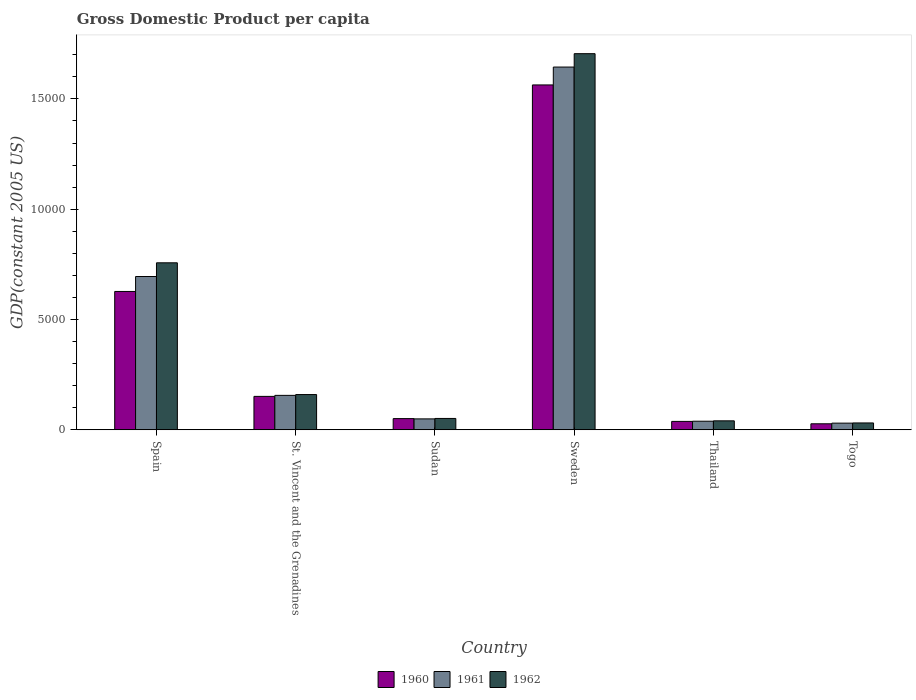How many different coloured bars are there?
Provide a succinct answer. 3. Are the number of bars per tick equal to the number of legend labels?
Keep it short and to the point. Yes. What is the label of the 2nd group of bars from the left?
Provide a short and direct response. St. Vincent and the Grenadines. What is the GDP per capita in 1962 in Sudan?
Your answer should be very brief. 515.24. Across all countries, what is the maximum GDP per capita in 1962?
Make the answer very short. 1.71e+04. Across all countries, what is the minimum GDP per capita in 1961?
Provide a succinct answer. 302.44. In which country was the GDP per capita in 1960 minimum?
Offer a very short reply. Togo. What is the total GDP per capita in 1960 in the graph?
Give a very brief answer. 2.46e+04. What is the difference between the GDP per capita in 1960 in Sweden and that in Thailand?
Your answer should be very brief. 1.53e+04. What is the difference between the GDP per capita in 1961 in Togo and the GDP per capita in 1962 in Spain?
Give a very brief answer. -7268.8. What is the average GDP per capita in 1962 per country?
Give a very brief answer. 4575.63. What is the difference between the GDP per capita of/in 1960 and GDP per capita of/in 1961 in St. Vincent and the Grenadines?
Offer a very short reply. -45.55. What is the ratio of the GDP per capita in 1960 in Spain to that in Sudan?
Ensure brevity in your answer.  12.35. Is the GDP per capita in 1961 in Sweden less than that in Thailand?
Provide a short and direct response. No. Is the difference between the GDP per capita in 1960 in Sweden and Togo greater than the difference between the GDP per capita in 1961 in Sweden and Togo?
Keep it short and to the point. No. What is the difference between the highest and the second highest GDP per capita in 1962?
Offer a very short reply. 9480.54. What is the difference between the highest and the lowest GDP per capita in 1960?
Provide a short and direct response. 1.54e+04. In how many countries, is the GDP per capita in 1961 greater than the average GDP per capita in 1961 taken over all countries?
Your answer should be very brief. 2. Is the sum of the GDP per capita in 1962 in Spain and Togo greater than the maximum GDP per capita in 1961 across all countries?
Ensure brevity in your answer.  No. How many countries are there in the graph?
Provide a short and direct response. 6. What is the difference between two consecutive major ticks on the Y-axis?
Make the answer very short. 5000. Does the graph contain grids?
Your answer should be compact. No. How are the legend labels stacked?
Offer a very short reply. Horizontal. What is the title of the graph?
Ensure brevity in your answer.  Gross Domestic Product per capita. Does "1961" appear as one of the legend labels in the graph?
Your answer should be compact. Yes. What is the label or title of the Y-axis?
Offer a very short reply. GDP(constant 2005 US). What is the GDP(constant 2005 US) in 1960 in Spain?
Your answer should be very brief. 6271.86. What is the GDP(constant 2005 US) of 1961 in Spain?
Your answer should be very brief. 6949.5. What is the GDP(constant 2005 US) of 1962 in Spain?
Offer a very short reply. 7571.23. What is the GDP(constant 2005 US) in 1960 in St. Vincent and the Grenadines?
Provide a short and direct response. 1515.48. What is the GDP(constant 2005 US) in 1961 in St. Vincent and the Grenadines?
Provide a succinct answer. 1561.03. What is the GDP(constant 2005 US) in 1962 in St. Vincent and the Grenadines?
Give a very brief answer. 1598.04. What is the GDP(constant 2005 US) in 1960 in Sudan?
Your answer should be compact. 507.97. What is the GDP(constant 2005 US) of 1961 in Sudan?
Ensure brevity in your answer.  494.94. What is the GDP(constant 2005 US) of 1962 in Sudan?
Keep it short and to the point. 515.24. What is the GDP(constant 2005 US) of 1960 in Sweden?
Your answer should be very brief. 1.56e+04. What is the GDP(constant 2005 US) in 1961 in Sweden?
Ensure brevity in your answer.  1.64e+04. What is the GDP(constant 2005 US) in 1962 in Sweden?
Your answer should be very brief. 1.71e+04. What is the GDP(constant 2005 US) of 1960 in Thailand?
Your response must be concise. 380.85. What is the GDP(constant 2005 US) of 1961 in Thailand?
Give a very brief answer. 389.52. What is the GDP(constant 2005 US) of 1962 in Thailand?
Your response must be concise. 406.6. What is the GDP(constant 2005 US) of 1960 in Togo?
Offer a terse response. 272.53. What is the GDP(constant 2005 US) in 1961 in Togo?
Keep it short and to the point. 302.44. What is the GDP(constant 2005 US) in 1962 in Togo?
Your response must be concise. 310.89. Across all countries, what is the maximum GDP(constant 2005 US) in 1960?
Offer a very short reply. 1.56e+04. Across all countries, what is the maximum GDP(constant 2005 US) in 1961?
Provide a succinct answer. 1.64e+04. Across all countries, what is the maximum GDP(constant 2005 US) in 1962?
Provide a succinct answer. 1.71e+04. Across all countries, what is the minimum GDP(constant 2005 US) in 1960?
Keep it short and to the point. 272.53. Across all countries, what is the minimum GDP(constant 2005 US) in 1961?
Give a very brief answer. 302.44. Across all countries, what is the minimum GDP(constant 2005 US) of 1962?
Offer a terse response. 310.89. What is the total GDP(constant 2005 US) in 1960 in the graph?
Make the answer very short. 2.46e+04. What is the total GDP(constant 2005 US) of 1961 in the graph?
Ensure brevity in your answer.  2.61e+04. What is the total GDP(constant 2005 US) in 1962 in the graph?
Give a very brief answer. 2.75e+04. What is the difference between the GDP(constant 2005 US) of 1960 in Spain and that in St. Vincent and the Grenadines?
Provide a short and direct response. 4756.38. What is the difference between the GDP(constant 2005 US) of 1961 in Spain and that in St. Vincent and the Grenadines?
Make the answer very short. 5388.47. What is the difference between the GDP(constant 2005 US) in 1962 in Spain and that in St. Vincent and the Grenadines?
Provide a short and direct response. 5973.2. What is the difference between the GDP(constant 2005 US) of 1960 in Spain and that in Sudan?
Ensure brevity in your answer.  5763.88. What is the difference between the GDP(constant 2005 US) in 1961 in Spain and that in Sudan?
Your answer should be very brief. 6454.56. What is the difference between the GDP(constant 2005 US) of 1962 in Spain and that in Sudan?
Give a very brief answer. 7055.99. What is the difference between the GDP(constant 2005 US) in 1960 in Spain and that in Sweden?
Your answer should be compact. -9363.18. What is the difference between the GDP(constant 2005 US) in 1961 in Spain and that in Sweden?
Your answer should be very brief. -9496.2. What is the difference between the GDP(constant 2005 US) of 1962 in Spain and that in Sweden?
Your answer should be compact. -9480.54. What is the difference between the GDP(constant 2005 US) in 1960 in Spain and that in Thailand?
Your answer should be very brief. 5891. What is the difference between the GDP(constant 2005 US) in 1961 in Spain and that in Thailand?
Give a very brief answer. 6559.98. What is the difference between the GDP(constant 2005 US) in 1962 in Spain and that in Thailand?
Your answer should be very brief. 7164.64. What is the difference between the GDP(constant 2005 US) in 1960 in Spain and that in Togo?
Give a very brief answer. 5999.33. What is the difference between the GDP(constant 2005 US) of 1961 in Spain and that in Togo?
Give a very brief answer. 6647.06. What is the difference between the GDP(constant 2005 US) of 1962 in Spain and that in Togo?
Make the answer very short. 7260.35. What is the difference between the GDP(constant 2005 US) in 1960 in St. Vincent and the Grenadines and that in Sudan?
Your response must be concise. 1007.51. What is the difference between the GDP(constant 2005 US) in 1961 in St. Vincent and the Grenadines and that in Sudan?
Your response must be concise. 1066.09. What is the difference between the GDP(constant 2005 US) of 1962 in St. Vincent and the Grenadines and that in Sudan?
Your response must be concise. 1082.79. What is the difference between the GDP(constant 2005 US) of 1960 in St. Vincent and the Grenadines and that in Sweden?
Offer a very short reply. -1.41e+04. What is the difference between the GDP(constant 2005 US) in 1961 in St. Vincent and the Grenadines and that in Sweden?
Offer a terse response. -1.49e+04. What is the difference between the GDP(constant 2005 US) of 1962 in St. Vincent and the Grenadines and that in Sweden?
Provide a short and direct response. -1.55e+04. What is the difference between the GDP(constant 2005 US) in 1960 in St. Vincent and the Grenadines and that in Thailand?
Provide a short and direct response. 1134.63. What is the difference between the GDP(constant 2005 US) in 1961 in St. Vincent and the Grenadines and that in Thailand?
Provide a succinct answer. 1171.51. What is the difference between the GDP(constant 2005 US) in 1962 in St. Vincent and the Grenadines and that in Thailand?
Your answer should be very brief. 1191.44. What is the difference between the GDP(constant 2005 US) in 1960 in St. Vincent and the Grenadines and that in Togo?
Ensure brevity in your answer.  1242.95. What is the difference between the GDP(constant 2005 US) in 1961 in St. Vincent and the Grenadines and that in Togo?
Your response must be concise. 1258.59. What is the difference between the GDP(constant 2005 US) in 1962 in St. Vincent and the Grenadines and that in Togo?
Provide a short and direct response. 1287.15. What is the difference between the GDP(constant 2005 US) of 1960 in Sudan and that in Sweden?
Offer a terse response. -1.51e+04. What is the difference between the GDP(constant 2005 US) of 1961 in Sudan and that in Sweden?
Offer a very short reply. -1.60e+04. What is the difference between the GDP(constant 2005 US) of 1962 in Sudan and that in Sweden?
Offer a very short reply. -1.65e+04. What is the difference between the GDP(constant 2005 US) in 1960 in Sudan and that in Thailand?
Your answer should be very brief. 127.12. What is the difference between the GDP(constant 2005 US) in 1961 in Sudan and that in Thailand?
Provide a short and direct response. 105.42. What is the difference between the GDP(constant 2005 US) in 1962 in Sudan and that in Thailand?
Your answer should be very brief. 108.64. What is the difference between the GDP(constant 2005 US) of 1960 in Sudan and that in Togo?
Keep it short and to the point. 235.45. What is the difference between the GDP(constant 2005 US) of 1961 in Sudan and that in Togo?
Offer a very short reply. 192.5. What is the difference between the GDP(constant 2005 US) of 1962 in Sudan and that in Togo?
Provide a succinct answer. 204.36. What is the difference between the GDP(constant 2005 US) in 1960 in Sweden and that in Thailand?
Ensure brevity in your answer.  1.53e+04. What is the difference between the GDP(constant 2005 US) in 1961 in Sweden and that in Thailand?
Keep it short and to the point. 1.61e+04. What is the difference between the GDP(constant 2005 US) of 1962 in Sweden and that in Thailand?
Your answer should be compact. 1.66e+04. What is the difference between the GDP(constant 2005 US) of 1960 in Sweden and that in Togo?
Your answer should be compact. 1.54e+04. What is the difference between the GDP(constant 2005 US) in 1961 in Sweden and that in Togo?
Your answer should be very brief. 1.61e+04. What is the difference between the GDP(constant 2005 US) in 1962 in Sweden and that in Togo?
Your answer should be compact. 1.67e+04. What is the difference between the GDP(constant 2005 US) of 1960 in Thailand and that in Togo?
Ensure brevity in your answer.  108.32. What is the difference between the GDP(constant 2005 US) of 1961 in Thailand and that in Togo?
Your answer should be compact. 87.08. What is the difference between the GDP(constant 2005 US) of 1962 in Thailand and that in Togo?
Provide a succinct answer. 95.71. What is the difference between the GDP(constant 2005 US) in 1960 in Spain and the GDP(constant 2005 US) in 1961 in St. Vincent and the Grenadines?
Ensure brevity in your answer.  4710.83. What is the difference between the GDP(constant 2005 US) of 1960 in Spain and the GDP(constant 2005 US) of 1962 in St. Vincent and the Grenadines?
Your answer should be very brief. 4673.82. What is the difference between the GDP(constant 2005 US) in 1961 in Spain and the GDP(constant 2005 US) in 1962 in St. Vincent and the Grenadines?
Keep it short and to the point. 5351.46. What is the difference between the GDP(constant 2005 US) of 1960 in Spain and the GDP(constant 2005 US) of 1961 in Sudan?
Your answer should be very brief. 5776.92. What is the difference between the GDP(constant 2005 US) in 1960 in Spain and the GDP(constant 2005 US) in 1962 in Sudan?
Keep it short and to the point. 5756.61. What is the difference between the GDP(constant 2005 US) in 1961 in Spain and the GDP(constant 2005 US) in 1962 in Sudan?
Make the answer very short. 6434.26. What is the difference between the GDP(constant 2005 US) of 1960 in Spain and the GDP(constant 2005 US) of 1961 in Sweden?
Your answer should be compact. -1.02e+04. What is the difference between the GDP(constant 2005 US) of 1960 in Spain and the GDP(constant 2005 US) of 1962 in Sweden?
Keep it short and to the point. -1.08e+04. What is the difference between the GDP(constant 2005 US) in 1961 in Spain and the GDP(constant 2005 US) in 1962 in Sweden?
Provide a short and direct response. -1.01e+04. What is the difference between the GDP(constant 2005 US) in 1960 in Spain and the GDP(constant 2005 US) in 1961 in Thailand?
Your answer should be compact. 5882.34. What is the difference between the GDP(constant 2005 US) of 1960 in Spain and the GDP(constant 2005 US) of 1962 in Thailand?
Your response must be concise. 5865.26. What is the difference between the GDP(constant 2005 US) in 1961 in Spain and the GDP(constant 2005 US) in 1962 in Thailand?
Give a very brief answer. 6542.9. What is the difference between the GDP(constant 2005 US) of 1960 in Spain and the GDP(constant 2005 US) of 1961 in Togo?
Your answer should be compact. 5969.42. What is the difference between the GDP(constant 2005 US) in 1960 in Spain and the GDP(constant 2005 US) in 1962 in Togo?
Keep it short and to the point. 5960.97. What is the difference between the GDP(constant 2005 US) of 1961 in Spain and the GDP(constant 2005 US) of 1962 in Togo?
Ensure brevity in your answer.  6638.61. What is the difference between the GDP(constant 2005 US) in 1960 in St. Vincent and the Grenadines and the GDP(constant 2005 US) in 1961 in Sudan?
Your response must be concise. 1020.54. What is the difference between the GDP(constant 2005 US) in 1960 in St. Vincent and the Grenadines and the GDP(constant 2005 US) in 1962 in Sudan?
Keep it short and to the point. 1000.24. What is the difference between the GDP(constant 2005 US) of 1961 in St. Vincent and the Grenadines and the GDP(constant 2005 US) of 1962 in Sudan?
Make the answer very short. 1045.78. What is the difference between the GDP(constant 2005 US) of 1960 in St. Vincent and the Grenadines and the GDP(constant 2005 US) of 1961 in Sweden?
Keep it short and to the point. -1.49e+04. What is the difference between the GDP(constant 2005 US) in 1960 in St. Vincent and the Grenadines and the GDP(constant 2005 US) in 1962 in Sweden?
Your answer should be very brief. -1.55e+04. What is the difference between the GDP(constant 2005 US) in 1961 in St. Vincent and the Grenadines and the GDP(constant 2005 US) in 1962 in Sweden?
Ensure brevity in your answer.  -1.55e+04. What is the difference between the GDP(constant 2005 US) in 1960 in St. Vincent and the Grenadines and the GDP(constant 2005 US) in 1961 in Thailand?
Your answer should be compact. 1125.96. What is the difference between the GDP(constant 2005 US) of 1960 in St. Vincent and the Grenadines and the GDP(constant 2005 US) of 1962 in Thailand?
Keep it short and to the point. 1108.88. What is the difference between the GDP(constant 2005 US) in 1961 in St. Vincent and the Grenadines and the GDP(constant 2005 US) in 1962 in Thailand?
Your answer should be very brief. 1154.43. What is the difference between the GDP(constant 2005 US) of 1960 in St. Vincent and the Grenadines and the GDP(constant 2005 US) of 1961 in Togo?
Your answer should be compact. 1213.04. What is the difference between the GDP(constant 2005 US) of 1960 in St. Vincent and the Grenadines and the GDP(constant 2005 US) of 1962 in Togo?
Provide a short and direct response. 1204.6. What is the difference between the GDP(constant 2005 US) in 1961 in St. Vincent and the Grenadines and the GDP(constant 2005 US) in 1962 in Togo?
Keep it short and to the point. 1250.14. What is the difference between the GDP(constant 2005 US) of 1960 in Sudan and the GDP(constant 2005 US) of 1961 in Sweden?
Your answer should be compact. -1.59e+04. What is the difference between the GDP(constant 2005 US) in 1960 in Sudan and the GDP(constant 2005 US) in 1962 in Sweden?
Your answer should be very brief. -1.65e+04. What is the difference between the GDP(constant 2005 US) in 1961 in Sudan and the GDP(constant 2005 US) in 1962 in Sweden?
Give a very brief answer. -1.66e+04. What is the difference between the GDP(constant 2005 US) of 1960 in Sudan and the GDP(constant 2005 US) of 1961 in Thailand?
Your answer should be very brief. 118.46. What is the difference between the GDP(constant 2005 US) in 1960 in Sudan and the GDP(constant 2005 US) in 1962 in Thailand?
Provide a succinct answer. 101.38. What is the difference between the GDP(constant 2005 US) of 1961 in Sudan and the GDP(constant 2005 US) of 1962 in Thailand?
Make the answer very short. 88.34. What is the difference between the GDP(constant 2005 US) of 1960 in Sudan and the GDP(constant 2005 US) of 1961 in Togo?
Give a very brief answer. 205.54. What is the difference between the GDP(constant 2005 US) of 1960 in Sudan and the GDP(constant 2005 US) of 1962 in Togo?
Give a very brief answer. 197.09. What is the difference between the GDP(constant 2005 US) in 1961 in Sudan and the GDP(constant 2005 US) in 1962 in Togo?
Ensure brevity in your answer.  184.05. What is the difference between the GDP(constant 2005 US) of 1960 in Sweden and the GDP(constant 2005 US) of 1961 in Thailand?
Offer a very short reply. 1.52e+04. What is the difference between the GDP(constant 2005 US) in 1960 in Sweden and the GDP(constant 2005 US) in 1962 in Thailand?
Your answer should be very brief. 1.52e+04. What is the difference between the GDP(constant 2005 US) in 1961 in Sweden and the GDP(constant 2005 US) in 1962 in Thailand?
Your response must be concise. 1.60e+04. What is the difference between the GDP(constant 2005 US) in 1960 in Sweden and the GDP(constant 2005 US) in 1961 in Togo?
Keep it short and to the point. 1.53e+04. What is the difference between the GDP(constant 2005 US) in 1960 in Sweden and the GDP(constant 2005 US) in 1962 in Togo?
Offer a terse response. 1.53e+04. What is the difference between the GDP(constant 2005 US) in 1961 in Sweden and the GDP(constant 2005 US) in 1962 in Togo?
Ensure brevity in your answer.  1.61e+04. What is the difference between the GDP(constant 2005 US) in 1960 in Thailand and the GDP(constant 2005 US) in 1961 in Togo?
Your answer should be very brief. 78.42. What is the difference between the GDP(constant 2005 US) in 1960 in Thailand and the GDP(constant 2005 US) in 1962 in Togo?
Make the answer very short. 69.97. What is the difference between the GDP(constant 2005 US) of 1961 in Thailand and the GDP(constant 2005 US) of 1962 in Togo?
Give a very brief answer. 78.63. What is the average GDP(constant 2005 US) in 1960 per country?
Your answer should be compact. 4097.29. What is the average GDP(constant 2005 US) in 1961 per country?
Make the answer very short. 4357.19. What is the average GDP(constant 2005 US) of 1962 per country?
Your response must be concise. 4575.63. What is the difference between the GDP(constant 2005 US) of 1960 and GDP(constant 2005 US) of 1961 in Spain?
Offer a very short reply. -677.64. What is the difference between the GDP(constant 2005 US) in 1960 and GDP(constant 2005 US) in 1962 in Spain?
Ensure brevity in your answer.  -1299.38. What is the difference between the GDP(constant 2005 US) in 1961 and GDP(constant 2005 US) in 1962 in Spain?
Give a very brief answer. -621.73. What is the difference between the GDP(constant 2005 US) in 1960 and GDP(constant 2005 US) in 1961 in St. Vincent and the Grenadines?
Offer a very short reply. -45.55. What is the difference between the GDP(constant 2005 US) of 1960 and GDP(constant 2005 US) of 1962 in St. Vincent and the Grenadines?
Your response must be concise. -82.55. What is the difference between the GDP(constant 2005 US) in 1961 and GDP(constant 2005 US) in 1962 in St. Vincent and the Grenadines?
Keep it short and to the point. -37.01. What is the difference between the GDP(constant 2005 US) in 1960 and GDP(constant 2005 US) in 1961 in Sudan?
Your response must be concise. 13.04. What is the difference between the GDP(constant 2005 US) of 1960 and GDP(constant 2005 US) of 1962 in Sudan?
Make the answer very short. -7.27. What is the difference between the GDP(constant 2005 US) in 1961 and GDP(constant 2005 US) in 1962 in Sudan?
Ensure brevity in your answer.  -20.31. What is the difference between the GDP(constant 2005 US) in 1960 and GDP(constant 2005 US) in 1961 in Sweden?
Ensure brevity in your answer.  -810.66. What is the difference between the GDP(constant 2005 US) in 1960 and GDP(constant 2005 US) in 1962 in Sweden?
Your answer should be compact. -1416.73. What is the difference between the GDP(constant 2005 US) in 1961 and GDP(constant 2005 US) in 1962 in Sweden?
Provide a succinct answer. -606.08. What is the difference between the GDP(constant 2005 US) of 1960 and GDP(constant 2005 US) of 1961 in Thailand?
Provide a short and direct response. -8.66. What is the difference between the GDP(constant 2005 US) of 1960 and GDP(constant 2005 US) of 1962 in Thailand?
Give a very brief answer. -25.75. What is the difference between the GDP(constant 2005 US) in 1961 and GDP(constant 2005 US) in 1962 in Thailand?
Offer a very short reply. -17.08. What is the difference between the GDP(constant 2005 US) of 1960 and GDP(constant 2005 US) of 1961 in Togo?
Offer a very short reply. -29.91. What is the difference between the GDP(constant 2005 US) of 1960 and GDP(constant 2005 US) of 1962 in Togo?
Give a very brief answer. -38.36. What is the difference between the GDP(constant 2005 US) of 1961 and GDP(constant 2005 US) of 1962 in Togo?
Give a very brief answer. -8.45. What is the ratio of the GDP(constant 2005 US) in 1960 in Spain to that in St. Vincent and the Grenadines?
Provide a short and direct response. 4.14. What is the ratio of the GDP(constant 2005 US) of 1961 in Spain to that in St. Vincent and the Grenadines?
Your response must be concise. 4.45. What is the ratio of the GDP(constant 2005 US) of 1962 in Spain to that in St. Vincent and the Grenadines?
Offer a terse response. 4.74. What is the ratio of the GDP(constant 2005 US) of 1960 in Spain to that in Sudan?
Provide a succinct answer. 12.35. What is the ratio of the GDP(constant 2005 US) of 1961 in Spain to that in Sudan?
Your response must be concise. 14.04. What is the ratio of the GDP(constant 2005 US) in 1962 in Spain to that in Sudan?
Offer a terse response. 14.69. What is the ratio of the GDP(constant 2005 US) of 1960 in Spain to that in Sweden?
Ensure brevity in your answer.  0.4. What is the ratio of the GDP(constant 2005 US) of 1961 in Spain to that in Sweden?
Keep it short and to the point. 0.42. What is the ratio of the GDP(constant 2005 US) of 1962 in Spain to that in Sweden?
Ensure brevity in your answer.  0.44. What is the ratio of the GDP(constant 2005 US) of 1960 in Spain to that in Thailand?
Give a very brief answer. 16.47. What is the ratio of the GDP(constant 2005 US) in 1961 in Spain to that in Thailand?
Your answer should be very brief. 17.84. What is the ratio of the GDP(constant 2005 US) of 1962 in Spain to that in Thailand?
Your response must be concise. 18.62. What is the ratio of the GDP(constant 2005 US) of 1960 in Spain to that in Togo?
Make the answer very short. 23.01. What is the ratio of the GDP(constant 2005 US) in 1961 in Spain to that in Togo?
Provide a succinct answer. 22.98. What is the ratio of the GDP(constant 2005 US) in 1962 in Spain to that in Togo?
Your response must be concise. 24.35. What is the ratio of the GDP(constant 2005 US) of 1960 in St. Vincent and the Grenadines to that in Sudan?
Offer a very short reply. 2.98. What is the ratio of the GDP(constant 2005 US) of 1961 in St. Vincent and the Grenadines to that in Sudan?
Your answer should be compact. 3.15. What is the ratio of the GDP(constant 2005 US) in 1962 in St. Vincent and the Grenadines to that in Sudan?
Ensure brevity in your answer.  3.1. What is the ratio of the GDP(constant 2005 US) of 1960 in St. Vincent and the Grenadines to that in Sweden?
Your answer should be compact. 0.1. What is the ratio of the GDP(constant 2005 US) of 1961 in St. Vincent and the Grenadines to that in Sweden?
Your answer should be compact. 0.09. What is the ratio of the GDP(constant 2005 US) of 1962 in St. Vincent and the Grenadines to that in Sweden?
Provide a succinct answer. 0.09. What is the ratio of the GDP(constant 2005 US) in 1960 in St. Vincent and the Grenadines to that in Thailand?
Make the answer very short. 3.98. What is the ratio of the GDP(constant 2005 US) in 1961 in St. Vincent and the Grenadines to that in Thailand?
Make the answer very short. 4.01. What is the ratio of the GDP(constant 2005 US) of 1962 in St. Vincent and the Grenadines to that in Thailand?
Your response must be concise. 3.93. What is the ratio of the GDP(constant 2005 US) in 1960 in St. Vincent and the Grenadines to that in Togo?
Keep it short and to the point. 5.56. What is the ratio of the GDP(constant 2005 US) of 1961 in St. Vincent and the Grenadines to that in Togo?
Ensure brevity in your answer.  5.16. What is the ratio of the GDP(constant 2005 US) in 1962 in St. Vincent and the Grenadines to that in Togo?
Your answer should be very brief. 5.14. What is the ratio of the GDP(constant 2005 US) in 1960 in Sudan to that in Sweden?
Give a very brief answer. 0.03. What is the ratio of the GDP(constant 2005 US) in 1961 in Sudan to that in Sweden?
Make the answer very short. 0.03. What is the ratio of the GDP(constant 2005 US) in 1962 in Sudan to that in Sweden?
Give a very brief answer. 0.03. What is the ratio of the GDP(constant 2005 US) in 1960 in Sudan to that in Thailand?
Your response must be concise. 1.33. What is the ratio of the GDP(constant 2005 US) of 1961 in Sudan to that in Thailand?
Give a very brief answer. 1.27. What is the ratio of the GDP(constant 2005 US) in 1962 in Sudan to that in Thailand?
Provide a short and direct response. 1.27. What is the ratio of the GDP(constant 2005 US) in 1960 in Sudan to that in Togo?
Provide a succinct answer. 1.86. What is the ratio of the GDP(constant 2005 US) of 1961 in Sudan to that in Togo?
Provide a short and direct response. 1.64. What is the ratio of the GDP(constant 2005 US) in 1962 in Sudan to that in Togo?
Offer a terse response. 1.66. What is the ratio of the GDP(constant 2005 US) of 1960 in Sweden to that in Thailand?
Keep it short and to the point. 41.05. What is the ratio of the GDP(constant 2005 US) in 1961 in Sweden to that in Thailand?
Provide a short and direct response. 42.22. What is the ratio of the GDP(constant 2005 US) of 1962 in Sweden to that in Thailand?
Offer a terse response. 41.94. What is the ratio of the GDP(constant 2005 US) of 1960 in Sweden to that in Togo?
Provide a short and direct response. 57.37. What is the ratio of the GDP(constant 2005 US) in 1961 in Sweden to that in Togo?
Keep it short and to the point. 54.38. What is the ratio of the GDP(constant 2005 US) in 1962 in Sweden to that in Togo?
Your answer should be very brief. 54.85. What is the ratio of the GDP(constant 2005 US) of 1960 in Thailand to that in Togo?
Provide a succinct answer. 1.4. What is the ratio of the GDP(constant 2005 US) of 1961 in Thailand to that in Togo?
Your response must be concise. 1.29. What is the ratio of the GDP(constant 2005 US) in 1962 in Thailand to that in Togo?
Ensure brevity in your answer.  1.31. What is the difference between the highest and the second highest GDP(constant 2005 US) of 1960?
Your answer should be compact. 9363.18. What is the difference between the highest and the second highest GDP(constant 2005 US) of 1961?
Your answer should be compact. 9496.2. What is the difference between the highest and the second highest GDP(constant 2005 US) in 1962?
Make the answer very short. 9480.54. What is the difference between the highest and the lowest GDP(constant 2005 US) of 1960?
Keep it short and to the point. 1.54e+04. What is the difference between the highest and the lowest GDP(constant 2005 US) in 1961?
Keep it short and to the point. 1.61e+04. What is the difference between the highest and the lowest GDP(constant 2005 US) of 1962?
Offer a very short reply. 1.67e+04. 